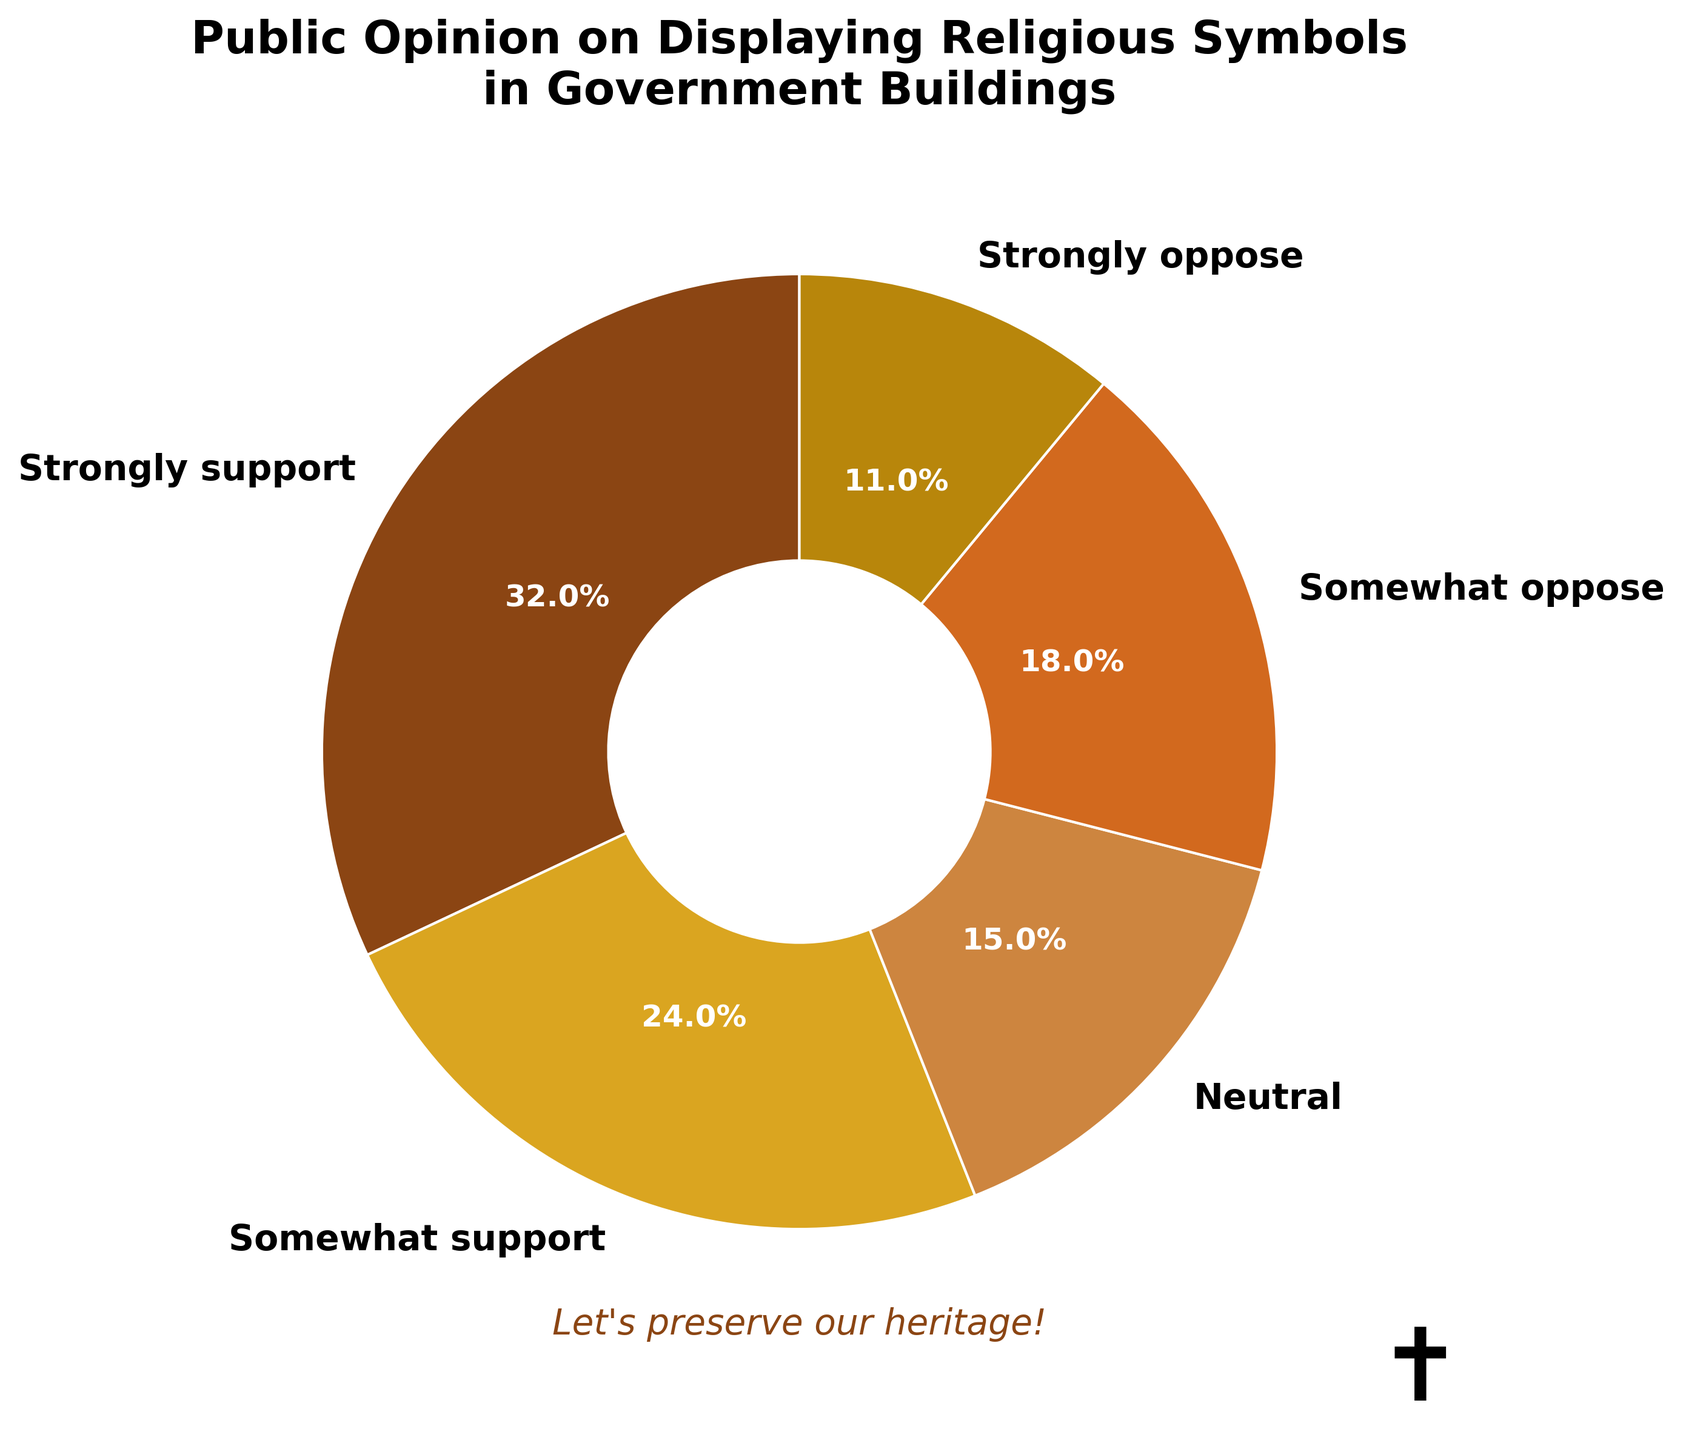What percentage of respondents support displaying religious symbols in government buildings? To find the percentage of respondents who support displaying religious symbols, sum the percentages of "Strongly support" and "Somewhat support." "Strongly support" is 32%, and "Somewhat support" is 24%. Therefore, 32% + 24% = 56%.
Answer: 56% Which opinion category has the smallest percentage of respondents? The smallest percentage among the categories is identified by looking at the pie chart. The category with the smallest percentage is "Strongly oppose" with 11%.
Answer: Strongly oppose How many more people strongly support than strongly oppose displaying religious symbols? To determine the difference, subtract the percentage of "Strongly oppose" from "Strongly support." "Strongly support" is 32%, and "Strongly oppose" is 11%. So, 32% - 11% = 21%.
Answer: 21% What is the combined percentage of respondents who are neutral or somewhat oppose? Sum the percentages of "Neutral" and "Somewhat oppose." "Neutral" is 15%, and "Somewhat oppose" is 18%. Therefore, 15% + 18% = 33%.
Answer: 33% Is there a greater percentage of people who are in support than those who are in opposition (somewhat and strongly combined)? Sum the percentages of "Strongly support" and "Somewhat support" to get the total support percentage, and sum "Somewhat oppose" and "Strongly oppose" for the total opposition percentage. Compare these sums: Support = 32% + 24% = 56%, Opposition = 18% + 11% = 29%. Since 56% > 29%, there is a greater percentage in support.
Answer: Yes What color represents the category with the highest percentage of respondents? By examining the pie chart colors, the segment representing the highest percentage, "Strongly support" (32%), has a brown-like color (likely represented by '#8B4513').
Answer: Brown Are there more respondents who somewhat support than those who somewhat oppose displaying religious symbols? Compare the percentages of "Somewhat support" and "Somewhat oppose." "Somewhat support" is 24%, and "Somewhat oppose" is 18%. Since 24% > 18%, there are more respondents who somewhat support.
Answer: Yes What is the difference in percentage between the highest and the lowest opinion categories? Subtract the smallest percentage from the largest percentage. The highest is "Strongly support" (32%) and the lowest is "Strongly oppose" (11%). Therefore, 32% - 11% = 21%.
Answer: 21% What percentage of respondents are either neutral or strongly oppose displaying religious symbols? Sum the percentages of "Neutral" and "Strongly oppose." "Neutral" is 15%, and "Strongly oppose" is 11%. Therefore, 15% + 11% = 26%.
Answer: 26% Which category is represented by the golden color? By visually examining the colors used, the golden color matches the "Somewhat support" category, which is 24%.
Answer: Somewhat support 